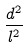Convert formula to latex. <formula><loc_0><loc_0><loc_500><loc_500>\frac { d ^ { 2 } } { l ^ { 2 } }</formula> 